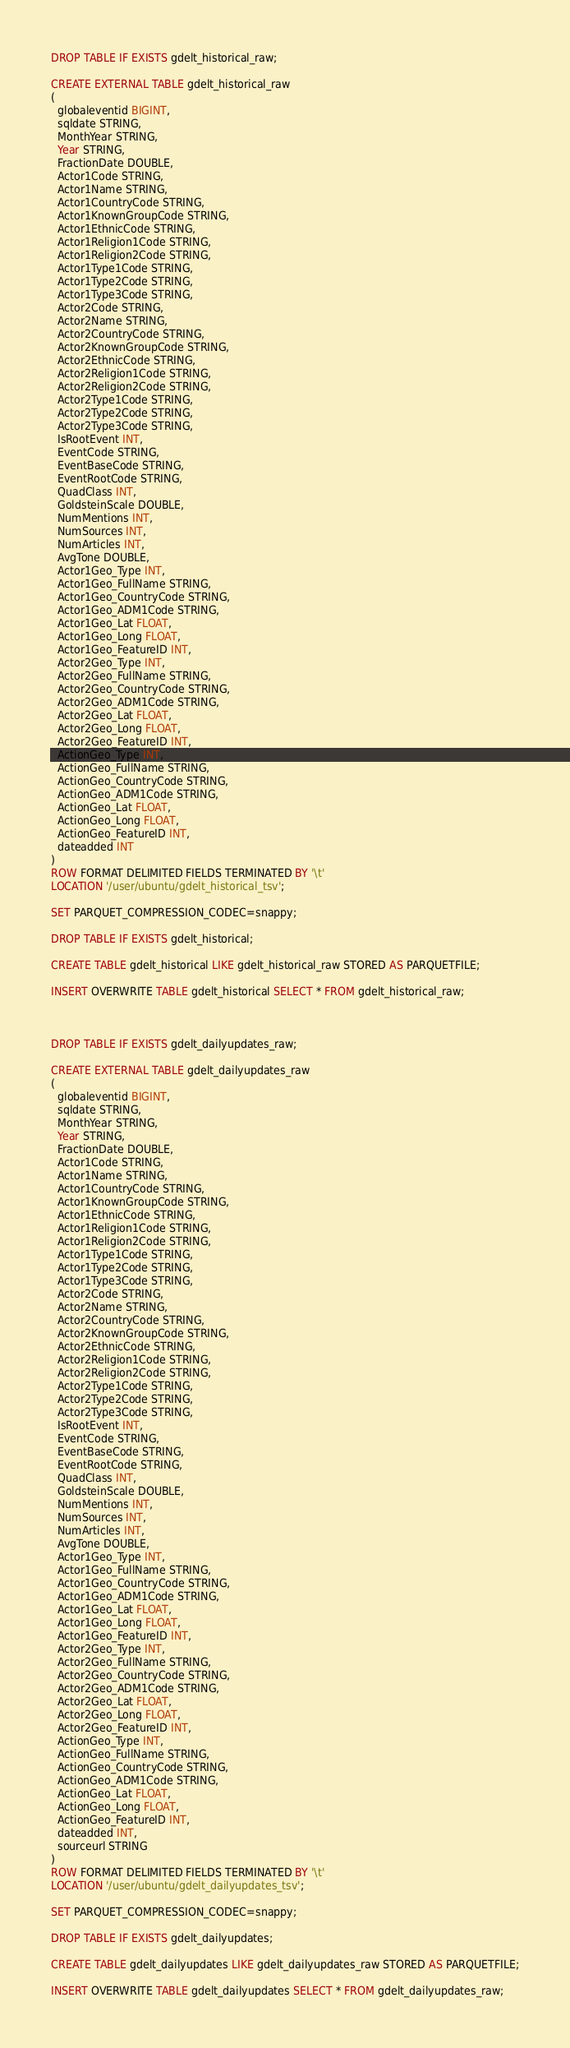<code> <loc_0><loc_0><loc_500><loc_500><_SQL_>
DROP TABLE IF EXISTS gdelt_historical_raw;

CREATE EXTERNAL TABLE gdelt_historical_raw
(
  globaleventid BIGINT, 
  sqldate STRING, 
  MonthYear STRING, 
  Year STRING, 
  FractionDate DOUBLE, 
  Actor1Code STRING, 
  Actor1Name STRING, 
  Actor1CountryCode STRING, 
  Actor1KnownGroupCode STRING, 
  Actor1EthnicCode STRING, 
  Actor1Religion1Code STRING, 
  Actor1Religion2Code STRING, 
  Actor1Type1Code STRING, 
  Actor1Type2Code STRING, 
  Actor1Type3Code STRING, 
  Actor2Code STRING, 
  Actor2Name STRING, 
  Actor2CountryCode STRING, 
  Actor2KnownGroupCode STRING, 
  Actor2EthnicCode STRING, 
  Actor2Religion1Code STRING, 
  Actor2Religion2Code STRING, 
  Actor2Type1Code STRING, 
  Actor2Type2Code STRING, 
  Actor2Type3Code STRING, 
  IsRootEvent INT, 
  EventCode STRING, 
  EventBaseCode STRING, 
  EventRootCode STRING, 
  QuadClass INT, 
  GoldsteinScale DOUBLE, 
  NumMentions INT, 
  NumSources INT, 
  NumArticles INT, 
  AvgTone DOUBLE, 
  Actor1Geo_Type INT, 
  Actor1Geo_FullName STRING, 
  Actor1Geo_CountryCode STRING, 
  Actor1Geo_ADM1Code STRING, 
  Actor1Geo_Lat FLOAT, 
  Actor1Geo_Long FLOAT, 
  Actor1Geo_FeatureID INT, 
  Actor2Geo_Type INT, 
  Actor2Geo_FullName STRING, 
  Actor2Geo_CountryCode STRING, 
  Actor2Geo_ADM1Code STRING, 
  Actor2Geo_Lat FLOAT, 
  Actor2Geo_Long FLOAT, 
  Actor2Geo_FeatureID INT, 
  ActionGeo_Type INT, 
  ActionGeo_FullName STRING, 
  ActionGeo_CountryCode STRING, 
  ActionGeo_ADM1Code STRING, 
  ActionGeo_Lat FLOAT, 
  ActionGeo_Long FLOAT, 
  ActionGeo_FeatureID INT, 
  dateadded INT
)
ROW FORMAT DELIMITED FIELDS TERMINATED BY '\t'
LOCATION '/user/ubuntu/gdelt_historical_tsv';

SET PARQUET_COMPRESSION_CODEC=snappy;

DROP TABLE IF EXISTS gdelt_historical;

CREATE TABLE gdelt_historical LIKE gdelt_historical_raw STORED AS PARQUETFILE;

INSERT OVERWRITE TABLE gdelt_historical SELECT * FROM gdelt_historical_raw;



DROP TABLE IF EXISTS gdelt_dailyupdates_raw;

CREATE EXTERNAL TABLE gdelt_dailyupdates_raw
(
  globaleventid BIGINT, 
  sqldate STRING, 
  MonthYear STRING, 
  Year STRING, 
  FractionDate DOUBLE, 
  Actor1Code STRING, 
  Actor1Name STRING, 
  Actor1CountryCode STRING, 
  Actor1KnownGroupCode STRING, 
  Actor1EthnicCode STRING, 
  Actor1Religion1Code STRING, 
  Actor1Religion2Code STRING, 
  Actor1Type1Code STRING, 
  Actor1Type2Code STRING, 
  Actor1Type3Code STRING, 
  Actor2Code STRING, 
  Actor2Name STRING, 
  Actor2CountryCode STRING, 
  Actor2KnownGroupCode STRING, 
  Actor2EthnicCode STRING, 
  Actor2Religion1Code STRING, 
  Actor2Religion2Code STRING, 
  Actor2Type1Code STRING, 
  Actor2Type2Code STRING, 
  Actor2Type3Code STRING, 
  IsRootEvent INT, 
  EventCode STRING, 
  EventBaseCode STRING, 
  EventRootCode STRING, 
  QuadClass INT, 
  GoldsteinScale DOUBLE, 
  NumMentions INT, 
  NumSources INT, 
  NumArticles INT, 
  AvgTone DOUBLE, 
  Actor1Geo_Type INT, 
  Actor1Geo_FullName STRING, 
  Actor1Geo_CountryCode STRING, 
  Actor1Geo_ADM1Code STRING, 
  Actor1Geo_Lat FLOAT, 
  Actor1Geo_Long FLOAT, 
  Actor1Geo_FeatureID INT, 
  Actor2Geo_Type INT, 
  Actor2Geo_FullName STRING, 
  Actor2Geo_CountryCode STRING, 
  Actor2Geo_ADM1Code STRING, 
  Actor2Geo_Lat FLOAT, 
  Actor2Geo_Long FLOAT, 
  Actor2Geo_FeatureID INT, 
  ActionGeo_Type INT, 
  ActionGeo_FullName STRING, 
  ActionGeo_CountryCode STRING, 
  ActionGeo_ADM1Code STRING, 
  ActionGeo_Lat FLOAT, 
  ActionGeo_Long FLOAT, 
  ActionGeo_FeatureID INT, 
  dateadded INT,
  sourceurl STRING 
)
ROW FORMAT DELIMITED FIELDS TERMINATED BY '\t'
LOCATION '/user/ubuntu/gdelt_dailyupdates_tsv';

SET PARQUET_COMPRESSION_CODEC=snappy;

DROP TABLE IF EXISTS gdelt_dailyupdates;

CREATE TABLE gdelt_dailyupdates LIKE gdelt_dailyupdates_raw STORED AS PARQUETFILE;

INSERT OVERWRITE TABLE gdelt_dailyupdates SELECT * FROM gdelt_dailyupdates_raw;



</code> 